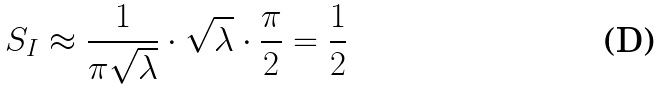Convert formula to latex. <formula><loc_0><loc_0><loc_500><loc_500>S _ { I } \approx \frac { 1 } { \pi \sqrt { \lambda } } \cdot \sqrt { \lambda } \cdot \frac { \pi } { 2 } = \frac { 1 } { 2 }</formula> 